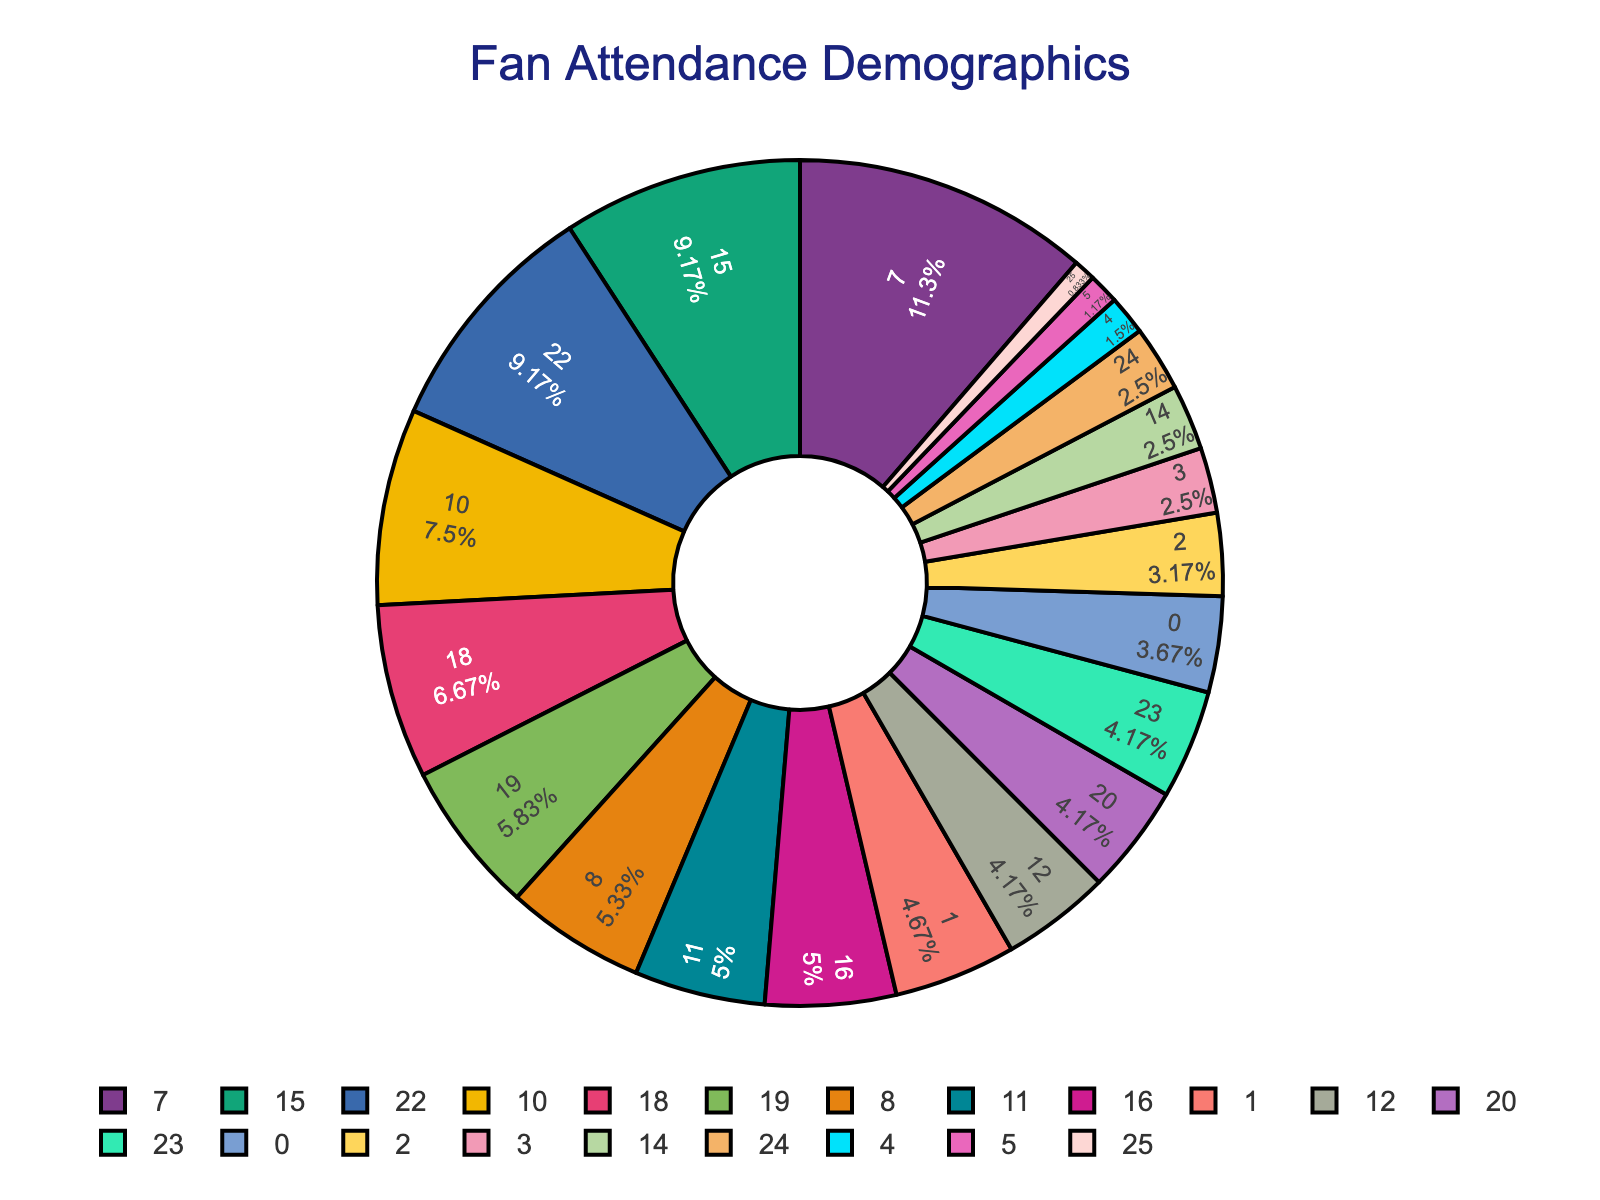Which age group has the highest percentage of fans? By looking at the slices of the pie chart for the different age groups, we can see that the age group with the largest slice represents 25-34.
Answer: 25-34 Which fan type makes up more than half of the attendees if we combine their percentages? Season Ticket Holders account for 45%, and Regular Attendees account for 30%. Combining these two percentages, 45% + 30% = 75%, which is more than half.
Answer: Season Ticket Holders and Regular Attendees What percentage of fans are either in the 18-24 or 35-44 age groups? The percentage for the 18-24 age group is 22%, and for the 35-44 age group, it is 19%. Adding these, 22% + 19% = 41%.
Answer: 41% Compare the proportion of male fans to female fans. By examining the pie chart slices for gender distribution, male fans make up 68%, while female fans make up 32%, indicating a notably larger proportion of male fans.
Answer: Males are 68%, Females are 32% What is the total percentage of fans who travel either locally or regionally? Local fans account for 40%, and regional fans account for 35%. Adding these percentages yields 40% + 35% = 75%.
Answer: 75% How does the proportion of high-income fans compare to low-income fans? The pie chart shows that high-income fans make up 30%, whereas low-income fans make up 15%. Thus, high-income fans are twice the proportion of low-income fans.
Answer: Twice as much What is the difference in percentage between fans attending some matches and those who attend most home matches? The percentage for fans attending some matches is 15%, while for those attending most home matches, it is 25%. The difference is 25% - 15% = 10%.
Answer: 10% What fraction of fans are occasional visitors? From the pie chart, occasional visitors represent 25% of the total fanbase. This can be converted into a fraction: 25% = 25/100 = 1/4.
Answer: 1/4 